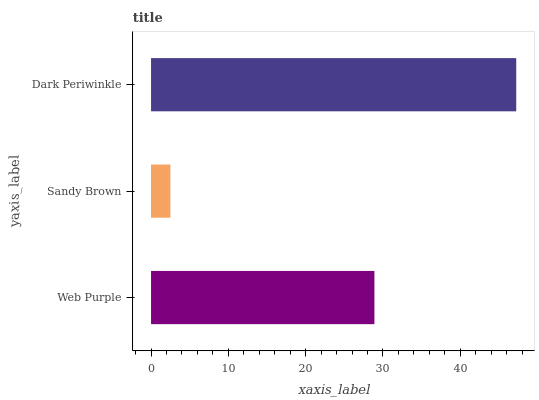Is Sandy Brown the minimum?
Answer yes or no. Yes. Is Dark Periwinkle the maximum?
Answer yes or no. Yes. Is Dark Periwinkle the minimum?
Answer yes or no. No. Is Sandy Brown the maximum?
Answer yes or no. No. Is Dark Periwinkle greater than Sandy Brown?
Answer yes or no. Yes. Is Sandy Brown less than Dark Periwinkle?
Answer yes or no. Yes. Is Sandy Brown greater than Dark Periwinkle?
Answer yes or no. No. Is Dark Periwinkle less than Sandy Brown?
Answer yes or no. No. Is Web Purple the high median?
Answer yes or no. Yes. Is Web Purple the low median?
Answer yes or no. Yes. Is Sandy Brown the high median?
Answer yes or no. No. Is Dark Periwinkle the low median?
Answer yes or no. No. 